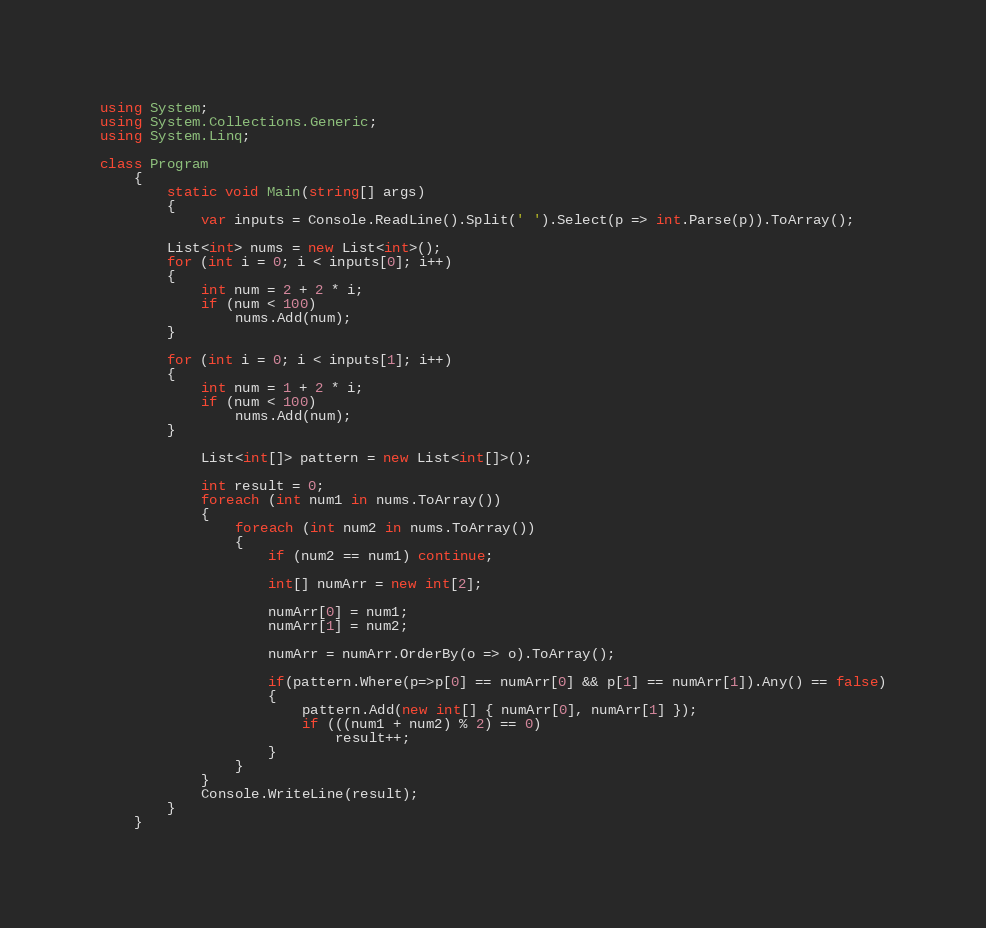Convert code to text. <code><loc_0><loc_0><loc_500><loc_500><_C#_>using System;
using System.Collections.Generic;
using System.Linq;

class Program
	{
		static void Main(string[] args)
		{
			var inputs = Console.ReadLine().Split(' ').Select(p => int.Parse(p)).ToArray();

		List<int> nums = new List<int>();
		for (int i = 0; i < inputs[0]; i++)
		{
			int num = 2 + 2 * i;
			if (num < 100)
				nums.Add(num);
		}

		for (int i = 0; i < inputs[1]; i++)
		{
			int num = 1 + 2 * i;
			if (num < 100)
				nums.Add(num);
		}

			List<int[]> pattern = new List<int[]>();

			int result = 0;
			foreach (int num1 in nums.ToArray())
			{
				foreach (int num2 in nums.ToArray())
				{
					if (num2 == num1) continue;

					int[] numArr = new int[2];

					numArr[0] = num1;
					numArr[1] = num2;

					numArr = numArr.OrderBy(o => o).ToArray();

					if(pattern.Where(p=>p[0] == numArr[0] && p[1] == numArr[1]).Any() == false)
					{
						pattern.Add(new int[] { numArr[0], numArr[1] });
						if (((num1 + num2) % 2) == 0)
							result++;
					}
				}
			}
			Console.WriteLine(result);
		}
	}</code> 